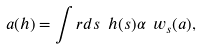<formula> <loc_0><loc_0><loc_500><loc_500>a ( h ) = \int _ { \ } r d s \ h ( s ) \alpha ^ { \ } w _ { s } ( a ) ,</formula> 